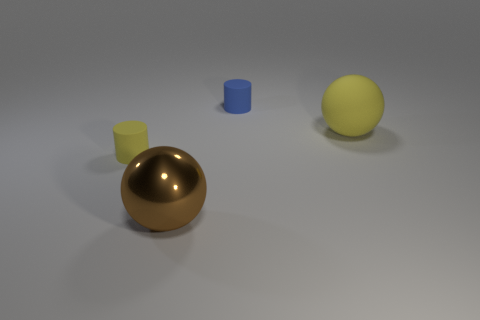Add 1 purple metallic balls. How many objects exist? 5 Subtract all brown rubber balls. Subtract all small blue cylinders. How many objects are left? 3 Add 2 metal objects. How many metal objects are left? 3 Add 4 big matte balls. How many big matte balls exist? 5 Subtract 0 purple cylinders. How many objects are left? 4 